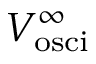<formula> <loc_0><loc_0><loc_500><loc_500>V _ { o s c i } ^ { \infty }</formula> 